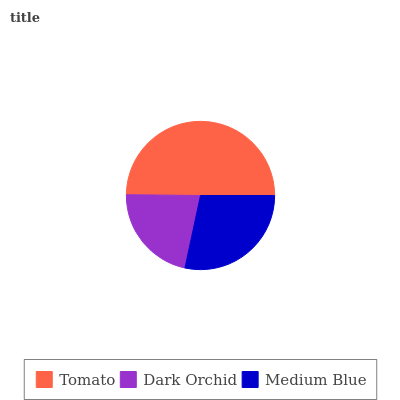Is Dark Orchid the minimum?
Answer yes or no. Yes. Is Tomato the maximum?
Answer yes or no. Yes. Is Medium Blue the minimum?
Answer yes or no. No. Is Medium Blue the maximum?
Answer yes or no. No. Is Medium Blue greater than Dark Orchid?
Answer yes or no. Yes. Is Dark Orchid less than Medium Blue?
Answer yes or no. Yes. Is Dark Orchid greater than Medium Blue?
Answer yes or no. No. Is Medium Blue less than Dark Orchid?
Answer yes or no. No. Is Medium Blue the high median?
Answer yes or no. Yes. Is Medium Blue the low median?
Answer yes or no. Yes. Is Dark Orchid the high median?
Answer yes or no. No. Is Tomato the low median?
Answer yes or no. No. 